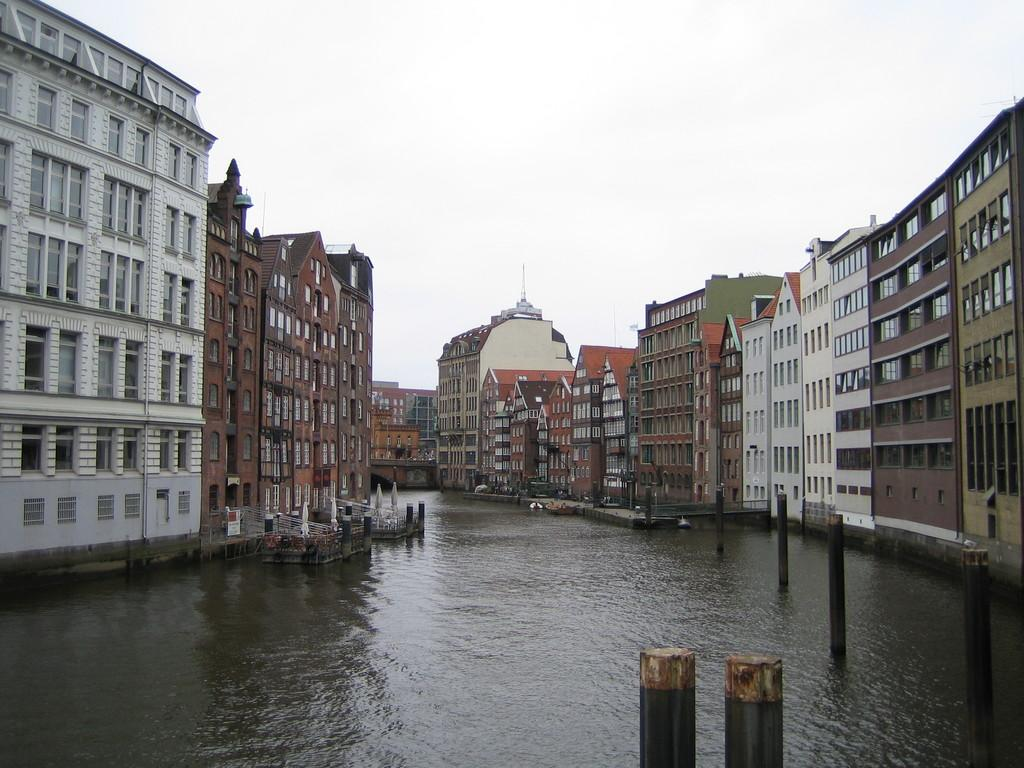What is located on the right side of the image? There are buildings on the right side of the image. What is located on the left side of the image? There are buildings on the left side of the image. What can be seen in the front portion of the image? There is water and rods in the front portion of the image. What is visible in the background of the image? The sky is visible in the background of the image. What type of berry is being held by the baby on the chin in the image? There are no babies or chins present in the image, and therefore no berries can be observed. 